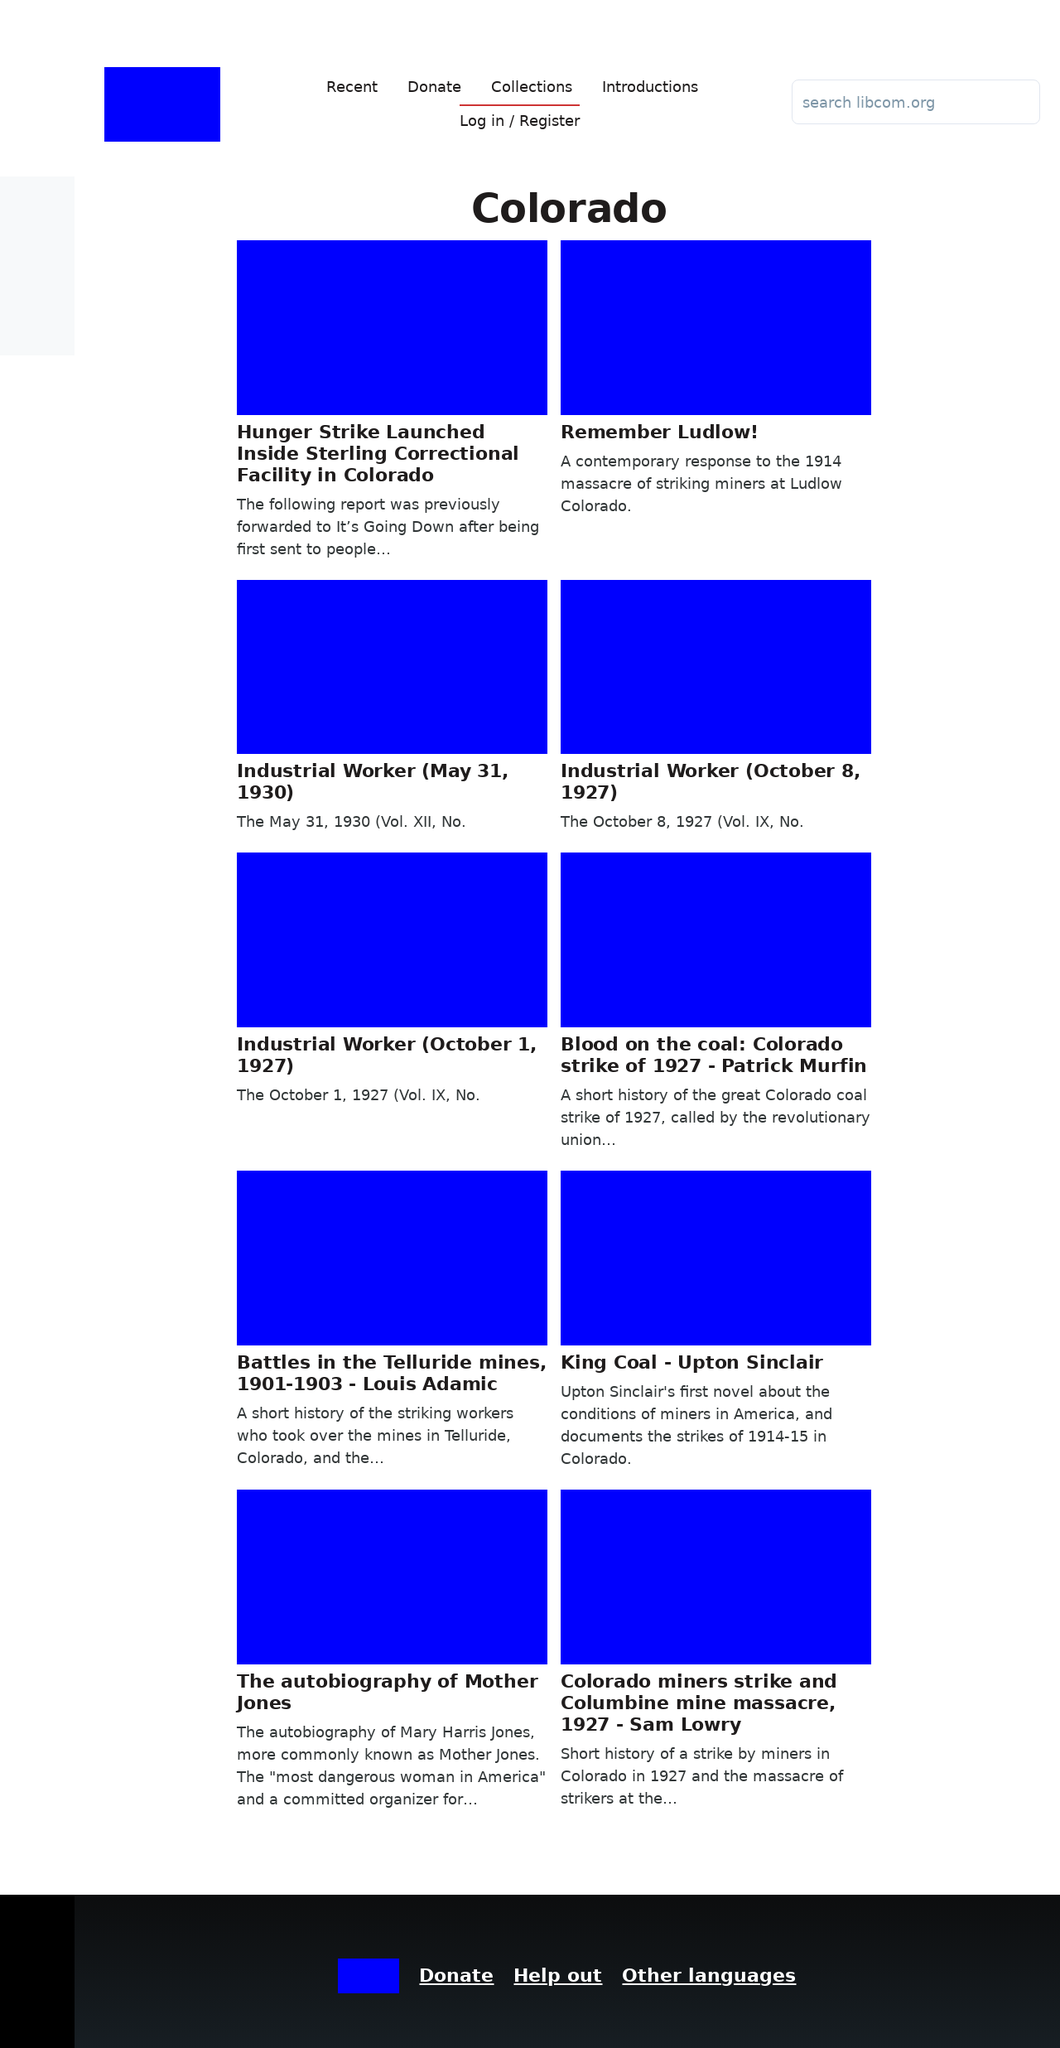Can you describe the main sections visible in this web page? The webpage primarily consists of a navigation bar, a main content area and the footer. The navigation bar includes links like 'Recent', 'Donate', 'Collections', and 'Introductions'. The main content area displays a series of articles related to Colorado, each summarizing historical events or discussions relevant to the region. Lastly, the footer likely contains links to additional pages or helps users navigate or contribute to the website. 